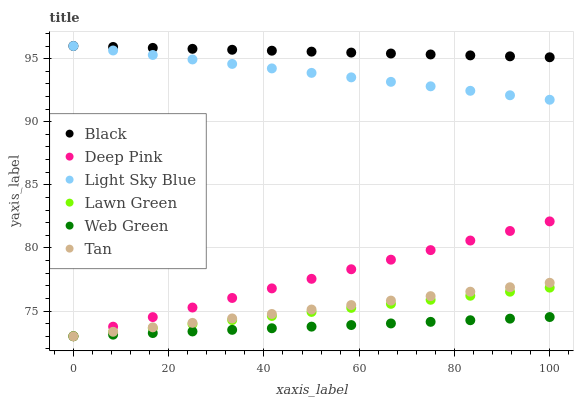Does Web Green have the minimum area under the curve?
Answer yes or no. Yes. Does Black have the maximum area under the curve?
Answer yes or no. Yes. Does Deep Pink have the minimum area under the curve?
Answer yes or no. No. Does Deep Pink have the maximum area under the curve?
Answer yes or no. No. Is Black the smoothest?
Answer yes or no. Yes. Is Light Sky Blue the roughest?
Answer yes or no. Yes. Is Deep Pink the smoothest?
Answer yes or no. No. Is Deep Pink the roughest?
Answer yes or no. No. Does Lawn Green have the lowest value?
Answer yes or no. Yes. Does Light Sky Blue have the lowest value?
Answer yes or no. No. Does Black have the highest value?
Answer yes or no. Yes. Does Deep Pink have the highest value?
Answer yes or no. No. Is Lawn Green less than Black?
Answer yes or no. Yes. Is Black greater than Web Green?
Answer yes or no. Yes. Does Black intersect Light Sky Blue?
Answer yes or no. Yes. Is Black less than Light Sky Blue?
Answer yes or no. No. Is Black greater than Light Sky Blue?
Answer yes or no. No. Does Lawn Green intersect Black?
Answer yes or no. No. 